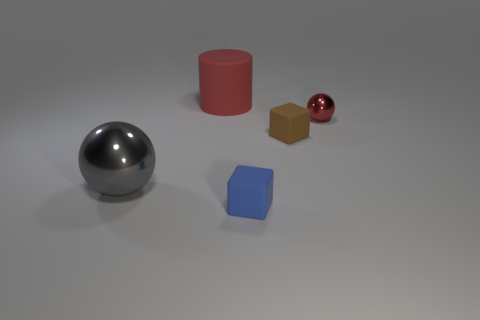What material is the tiny ball that is the same color as the large cylinder?
Keep it short and to the point. Metal. There is a big rubber cylinder that is behind the small blue matte thing; is it the same color as the small ball?
Provide a succinct answer. Yes. Is the number of tiny objects that are behind the small brown block the same as the number of big objects?
Offer a very short reply. No. Is there a metal thing of the same color as the small sphere?
Your response must be concise. No. Does the red shiny ball have the same size as the red matte thing?
Your answer should be compact. No. There is a sphere left of the metal thing that is on the right side of the gray object; what is its size?
Keep it short and to the point. Large. There is a thing that is both on the left side of the small blue cube and behind the large gray metallic thing; what is its size?
Ensure brevity in your answer.  Large. What number of balls are the same size as the gray thing?
Your answer should be very brief. 0. What number of matte objects are big objects or brown blocks?
Your answer should be very brief. 2. The thing that is the same color as the matte cylinder is what size?
Provide a short and direct response. Small. 